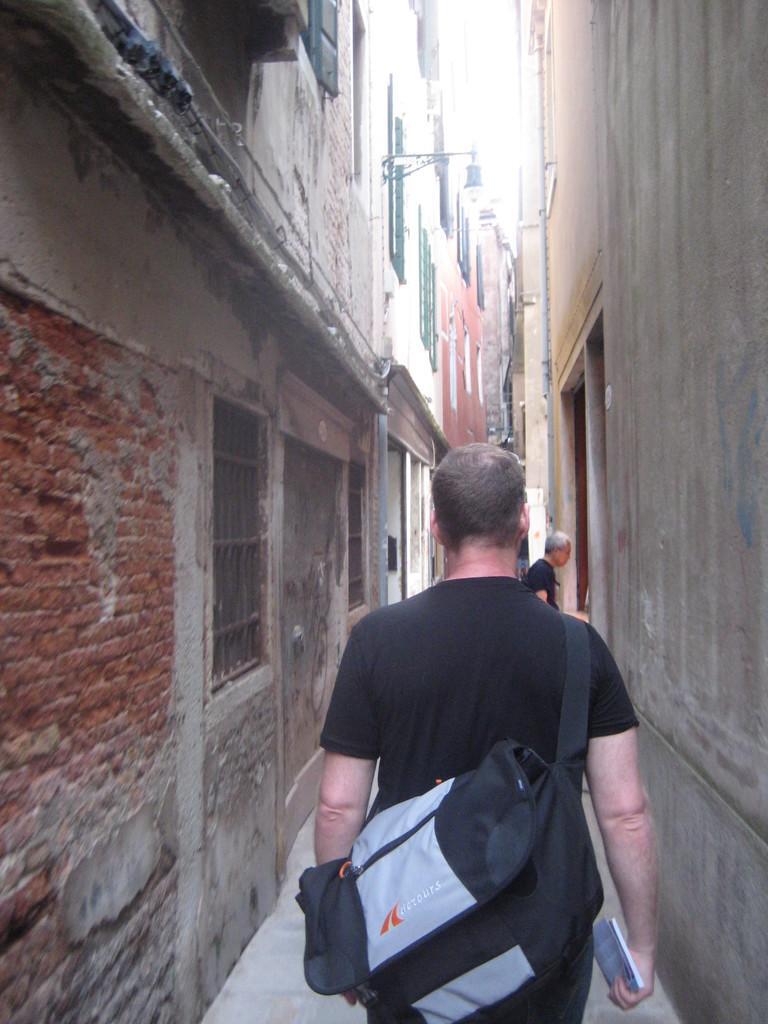Please provide a concise description of this image. The image is outside of the city. In the image man wearing a black color shirt holding a book on his hand and he also wearing backpack is walking. In background there is a another man wearing a black color shirt, on right side and left side we can also see buildings,windows. 